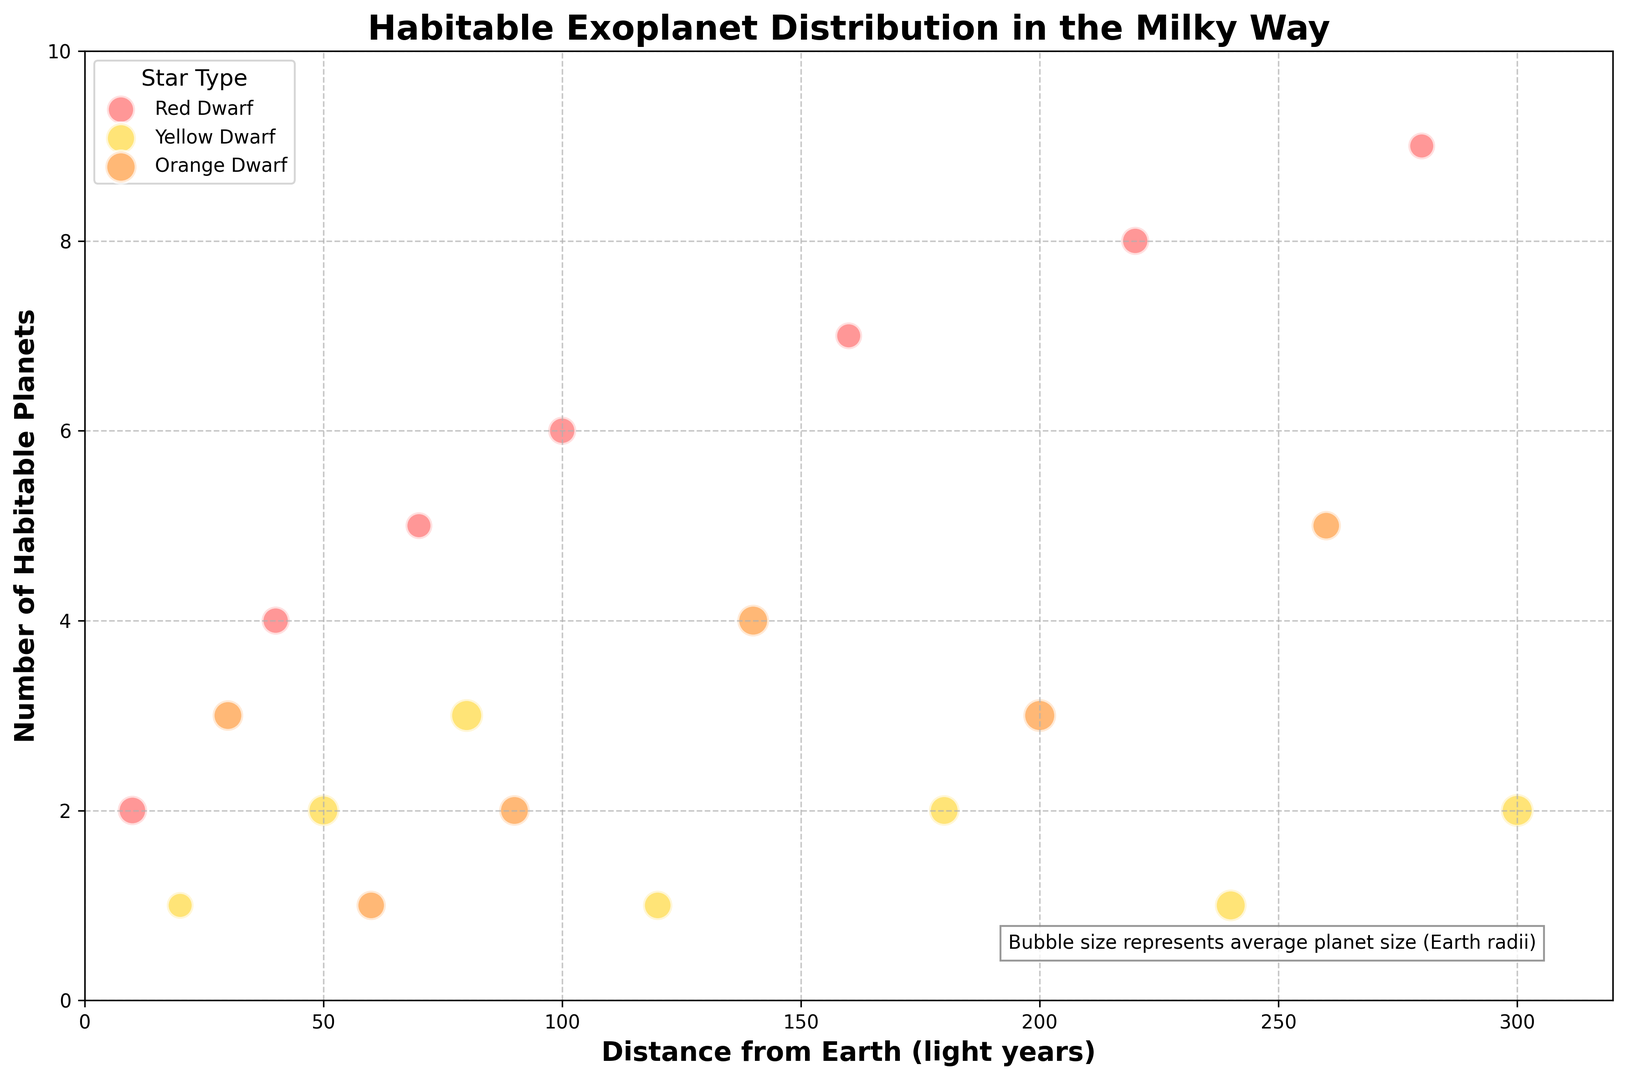What's the star type with the most habitable planets? To determine the star type with the most habitable planets, observe the y-axis ('Number of Habitable Planets') and identify which star type has the highest point. The red bubbles (Red Dwarf) reach a maximum of 9 habitable planets.
Answer: Red Dwarf Which star type has habitable planets at the greatest distance from Earth? Check the x-axis ('Distance from Earth') and see which star type's bubble reaches the furthest right. The orange bubbles (Orange Dwarf) are the farthest at 260+ light years.
Answer: Orange Dwarf How many habitable planets are around Red Dwarfs within 100 light years of Earth? Sum the number of habitable planets for Red Dwarf star types with distances up to 100 light years: 2 (10 ly) + 4 (40 ly) + 5 (70 ly) + 6 (100 ly) = 17.
Answer: 17 Compare the average planet size between Yellow Dwarfs and Red Dwarfs. Which is generally larger? Identify the size of the bubbles representing Yellow Dwarf and Red Dwarf star types. Yellow Dwarf bubbles, which are larger, indicate a larger average planet size.
Answer: Yellow Dwarfs What's the total number of habitable planets around all the observed Orange Dwarfs? Summing up the number of habitable planets around Orange Dwarfs: 3 (30 ly) + 1 (60 ly) + 2 (90 ly) + 4 (140 ly) + 3 (200 ly) + 5 (260 ly) = 18.
Answer: 18 Do Red Dwarfs have the smallest-sized habitable planets on average? Compare the sizes of the bubbles among the star types. Red Dwarf bubbles are generally smaller, indicating smaller average planet sizes.
Answer: Yes Which star type has a bubble suggesting a habitable planet closest to Earth with a size of 1.4 Earth radii? The bubble with a distance closest to Earth and a size of 1.4 Earth radii is yellow, corresponding to the Yellow Dwarf star type at 50 light years.
Answer: Yellow Dwarf How many habitable planets are there in total around stars within 50 light years? Add the number of habitable planets for all star types up to 50 light years: 2 (Red Dwarf at 10 ly) + 1 (Yellow Dwarf at 20 ly) + 3 (Orange Dwarf at 30 ly) + 4 (Red Dwarf at 40 ly) + 2 (Yellow Dwarf at 50 ly) = 12.
Answer: 12 For Orange Dwarfs, what is the trend of habitable planets with increasing distance from Earth? Observe the number of habitable planets for Orange Dwarf as distance increases: 3 (30 ly) then 1 (60 ly), then 2 (90 ly), and so on. The number fluctuates with no clear trend of increase or decrease.
Answer: No clear trend Are there any Yellow Dwarfs that host exactly one habitable planet? If so, where are they located? Look for yellow bubbles with a 'Number of Habitable Planets' value of 1. There are such Yellow Dwarfs at 20 and 120 light years from Earth.
Answer: Yes, at 20 and 120 light years 